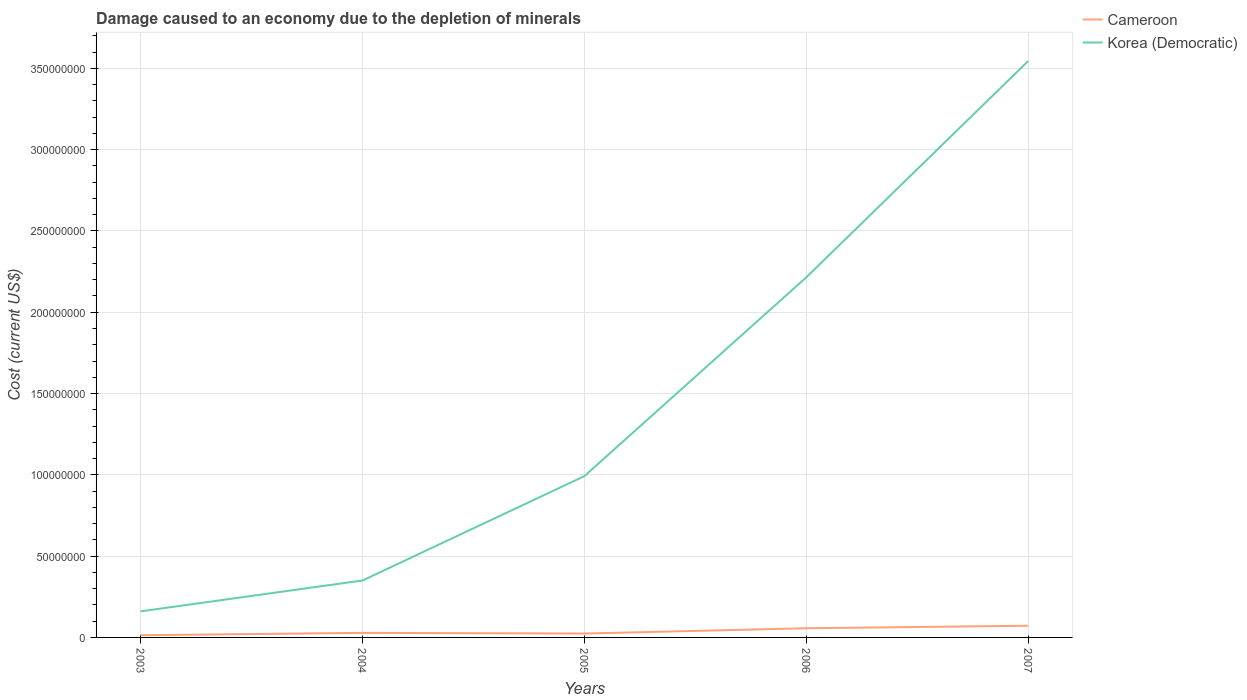How many different coloured lines are there?
Your answer should be compact. 2. Across all years, what is the maximum cost of damage caused due to the depletion of minerals in Cameroon?
Make the answer very short. 1.34e+06. In which year was the cost of damage caused due to the depletion of minerals in Korea (Democratic) maximum?
Your answer should be very brief. 2003. What is the total cost of damage caused due to the depletion of minerals in Cameroon in the graph?
Provide a succinct answer. -4.79e+06. What is the difference between the highest and the second highest cost of damage caused due to the depletion of minerals in Cameroon?
Ensure brevity in your answer.  5.83e+06. What is the difference between the highest and the lowest cost of damage caused due to the depletion of minerals in Cameroon?
Your response must be concise. 2. Are the values on the major ticks of Y-axis written in scientific E-notation?
Your answer should be compact. No. Does the graph contain grids?
Keep it short and to the point. Yes. How many legend labels are there?
Ensure brevity in your answer.  2. How are the legend labels stacked?
Provide a short and direct response. Vertical. What is the title of the graph?
Keep it short and to the point. Damage caused to an economy due to the depletion of minerals. What is the label or title of the X-axis?
Provide a short and direct response. Years. What is the label or title of the Y-axis?
Give a very brief answer. Cost (current US$). What is the Cost (current US$) of Cameroon in 2003?
Keep it short and to the point. 1.34e+06. What is the Cost (current US$) in Korea (Democratic) in 2003?
Ensure brevity in your answer.  1.60e+07. What is the Cost (current US$) of Cameroon in 2004?
Keep it short and to the point. 2.81e+06. What is the Cost (current US$) of Korea (Democratic) in 2004?
Give a very brief answer. 3.50e+07. What is the Cost (current US$) of Cameroon in 2005?
Provide a short and direct response. 2.39e+06. What is the Cost (current US$) of Korea (Democratic) in 2005?
Your answer should be compact. 9.92e+07. What is the Cost (current US$) of Cameroon in 2006?
Keep it short and to the point. 5.64e+06. What is the Cost (current US$) of Korea (Democratic) in 2006?
Provide a short and direct response. 2.21e+08. What is the Cost (current US$) of Cameroon in 2007?
Your answer should be compact. 7.18e+06. What is the Cost (current US$) in Korea (Democratic) in 2007?
Your answer should be very brief. 3.55e+08. Across all years, what is the maximum Cost (current US$) in Cameroon?
Give a very brief answer. 7.18e+06. Across all years, what is the maximum Cost (current US$) in Korea (Democratic)?
Your response must be concise. 3.55e+08. Across all years, what is the minimum Cost (current US$) in Cameroon?
Provide a short and direct response. 1.34e+06. Across all years, what is the minimum Cost (current US$) of Korea (Democratic)?
Offer a very short reply. 1.60e+07. What is the total Cost (current US$) in Cameroon in the graph?
Offer a very short reply. 1.94e+07. What is the total Cost (current US$) of Korea (Democratic) in the graph?
Ensure brevity in your answer.  7.26e+08. What is the difference between the Cost (current US$) of Cameroon in 2003 and that in 2004?
Provide a succinct answer. -1.47e+06. What is the difference between the Cost (current US$) in Korea (Democratic) in 2003 and that in 2004?
Make the answer very short. -1.90e+07. What is the difference between the Cost (current US$) in Cameroon in 2003 and that in 2005?
Your answer should be compact. -1.04e+06. What is the difference between the Cost (current US$) in Korea (Democratic) in 2003 and that in 2005?
Offer a very short reply. -8.32e+07. What is the difference between the Cost (current US$) in Cameroon in 2003 and that in 2006?
Provide a succinct answer. -4.30e+06. What is the difference between the Cost (current US$) in Korea (Democratic) in 2003 and that in 2006?
Make the answer very short. -2.05e+08. What is the difference between the Cost (current US$) of Cameroon in 2003 and that in 2007?
Your answer should be compact. -5.83e+06. What is the difference between the Cost (current US$) in Korea (Democratic) in 2003 and that in 2007?
Your answer should be very brief. -3.39e+08. What is the difference between the Cost (current US$) of Cameroon in 2004 and that in 2005?
Provide a succinct answer. 4.24e+05. What is the difference between the Cost (current US$) in Korea (Democratic) in 2004 and that in 2005?
Provide a succinct answer. -6.42e+07. What is the difference between the Cost (current US$) of Cameroon in 2004 and that in 2006?
Keep it short and to the point. -2.83e+06. What is the difference between the Cost (current US$) of Korea (Democratic) in 2004 and that in 2006?
Your answer should be very brief. -1.86e+08. What is the difference between the Cost (current US$) in Cameroon in 2004 and that in 2007?
Provide a succinct answer. -4.37e+06. What is the difference between the Cost (current US$) in Korea (Democratic) in 2004 and that in 2007?
Offer a terse response. -3.20e+08. What is the difference between the Cost (current US$) of Cameroon in 2005 and that in 2006?
Your answer should be compact. -3.25e+06. What is the difference between the Cost (current US$) of Korea (Democratic) in 2005 and that in 2006?
Keep it short and to the point. -1.22e+08. What is the difference between the Cost (current US$) of Cameroon in 2005 and that in 2007?
Your answer should be very brief. -4.79e+06. What is the difference between the Cost (current US$) of Korea (Democratic) in 2005 and that in 2007?
Give a very brief answer. -2.55e+08. What is the difference between the Cost (current US$) of Cameroon in 2006 and that in 2007?
Offer a terse response. -1.54e+06. What is the difference between the Cost (current US$) of Korea (Democratic) in 2006 and that in 2007?
Your answer should be compact. -1.33e+08. What is the difference between the Cost (current US$) of Cameroon in 2003 and the Cost (current US$) of Korea (Democratic) in 2004?
Give a very brief answer. -3.37e+07. What is the difference between the Cost (current US$) in Cameroon in 2003 and the Cost (current US$) in Korea (Democratic) in 2005?
Ensure brevity in your answer.  -9.79e+07. What is the difference between the Cost (current US$) in Cameroon in 2003 and the Cost (current US$) in Korea (Democratic) in 2006?
Provide a short and direct response. -2.20e+08. What is the difference between the Cost (current US$) of Cameroon in 2003 and the Cost (current US$) of Korea (Democratic) in 2007?
Your response must be concise. -3.53e+08. What is the difference between the Cost (current US$) in Cameroon in 2004 and the Cost (current US$) in Korea (Democratic) in 2005?
Give a very brief answer. -9.64e+07. What is the difference between the Cost (current US$) in Cameroon in 2004 and the Cost (current US$) in Korea (Democratic) in 2006?
Offer a terse response. -2.19e+08. What is the difference between the Cost (current US$) in Cameroon in 2004 and the Cost (current US$) in Korea (Democratic) in 2007?
Give a very brief answer. -3.52e+08. What is the difference between the Cost (current US$) of Cameroon in 2005 and the Cost (current US$) of Korea (Democratic) in 2006?
Give a very brief answer. -2.19e+08. What is the difference between the Cost (current US$) in Cameroon in 2005 and the Cost (current US$) in Korea (Democratic) in 2007?
Offer a terse response. -3.52e+08. What is the difference between the Cost (current US$) of Cameroon in 2006 and the Cost (current US$) of Korea (Democratic) in 2007?
Provide a short and direct response. -3.49e+08. What is the average Cost (current US$) of Cameroon per year?
Keep it short and to the point. 3.87e+06. What is the average Cost (current US$) of Korea (Democratic) per year?
Offer a very short reply. 1.45e+08. In the year 2003, what is the difference between the Cost (current US$) in Cameroon and Cost (current US$) in Korea (Democratic)?
Make the answer very short. -1.47e+07. In the year 2004, what is the difference between the Cost (current US$) of Cameroon and Cost (current US$) of Korea (Democratic)?
Keep it short and to the point. -3.22e+07. In the year 2005, what is the difference between the Cost (current US$) of Cameroon and Cost (current US$) of Korea (Democratic)?
Make the answer very short. -9.68e+07. In the year 2006, what is the difference between the Cost (current US$) in Cameroon and Cost (current US$) in Korea (Democratic)?
Give a very brief answer. -2.16e+08. In the year 2007, what is the difference between the Cost (current US$) in Cameroon and Cost (current US$) in Korea (Democratic)?
Give a very brief answer. -3.47e+08. What is the ratio of the Cost (current US$) in Cameroon in 2003 to that in 2004?
Make the answer very short. 0.48. What is the ratio of the Cost (current US$) in Korea (Democratic) in 2003 to that in 2004?
Your answer should be very brief. 0.46. What is the ratio of the Cost (current US$) of Cameroon in 2003 to that in 2005?
Provide a succinct answer. 0.56. What is the ratio of the Cost (current US$) of Korea (Democratic) in 2003 to that in 2005?
Your answer should be compact. 0.16. What is the ratio of the Cost (current US$) in Cameroon in 2003 to that in 2006?
Your answer should be compact. 0.24. What is the ratio of the Cost (current US$) in Korea (Democratic) in 2003 to that in 2006?
Keep it short and to the point. 0.07. What is the ratio of the Cost (current US$) of Cameroon in 2003 to that in 2007?
Your answer should be very brief. 0.19. What is the ratio of the Cost (current US$) of Korea (Democratic) in 2003 to that in 2007?
Ensure brevity in your answer.  0.05. What is the ratio of the Cost (current US$) in Cameroon in 2004 to that in 2005?
Offer a terse response. 1.18. What is the ratio of the Cost (current US$) in Korea (Democratic) in 2004 to that in 2005?
Make the answer very short. 0.35. What is the ratio of the Cost (current US$) of Cameroon in 2004 to that in 2006?
Make the answer very short. 0.5. What is the ratio of the Cost (current US$) in Korea (Democratic) in 2004 to that in 2006?
Your response must be concise. 0.16. What is the ratio of the Cost (current US$) in Cameroon in 2004 to that in 2007?
Your answer should be very brief. 0.39. What is the ratio of the Cost (current US$) of Korea (Democratic) in 2004 to that in 2007?
Give a very brief answer. 0.1. What is the ratio of the Cost (current US$) of Cameroon in 2005 to that in 2006?
Offer a terse response. 0.42. What is the ratio of the Cost (current US$) in Korea (Democratic) in 2005 to that in 2006?
Your answer should be very brief. 0.45. What is the ratio of the Cost (current US$) of Cameroon in 2005 to that in 2007?
Your response must be concise. 0.33. What is the ratio of the Cost (current US$) of Korea (Democratic) in 2005 to that in 2007?
Your answer should be very brief. 0.28. What is the ratio of the Cost (current US$) in Cameroon in 2006 to that in 2007?
Keep it short and to the point. 0.79. What is the ratio of the Cost (current US$) in Korea (Democratic) in 2006 to that in 2007?
Offer a very short reply. 0.62. What is the difference between the highest and the second highest Cost (current US$) in Cameroon?
Offer a very short reply. 1.54e+06. What is the difference between the highest and the second highest Cost (current US$) of Korea (Democratic)?
Your answer should be very brief. 1.33e+08. What is the difference between the highest and the lowest Cost (current US$) of Cameroon?
Keep it short and to the point. 5.83e+06. What is the difference between the highest and the lowest Cost (current US$) in Korea (Democratic)?
Offer a very short reply. 3.39e+08. 